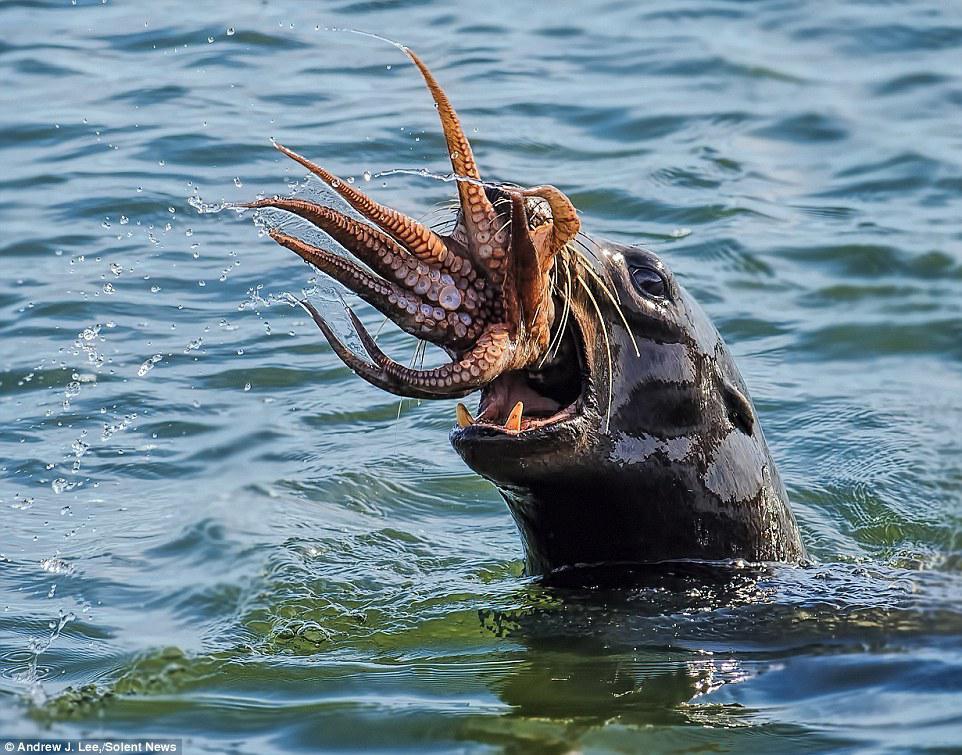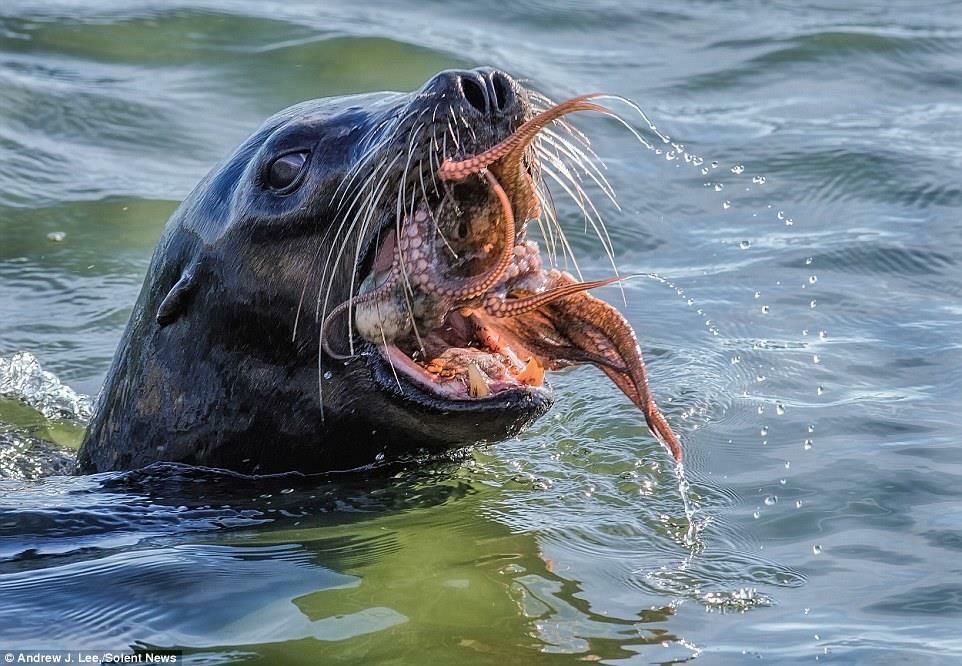The first image is the image on the left, the second image is the image on the right. Evaluate the accuracy of this statement regarding the images: "At least one image shows a sea lion with octopus tentacles in its mouth.". Is it true? Answer yes or no. Yes. The first image is the image on the left, the second image is the image on the right. Evaluate the accuracy of this statement regarding the images: "Atleast one image of a seal eating an octopus". Is it true? Answer yes or no. Yes. 